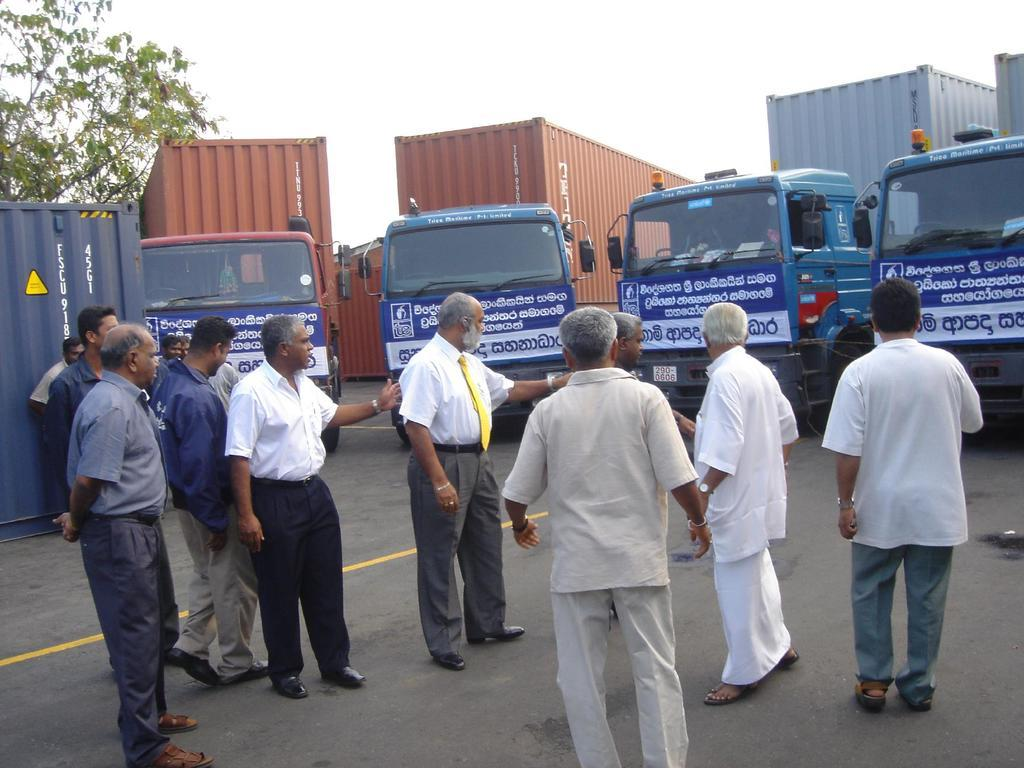What can be seen in the image involving people? There are people standing in the image. What else is visible on the surface besides people? There are vehicles visible on the surface. Where is the tree located in the image? The tree is on the left side of the image. What is visible in the background of the image? The sky is visible in the image. What language are the boys speaking on the stage in the image? There are no boys or stage present in the image. What type of language is being used by the people in the image? The image does not provide information about the language being spoken by the people. 